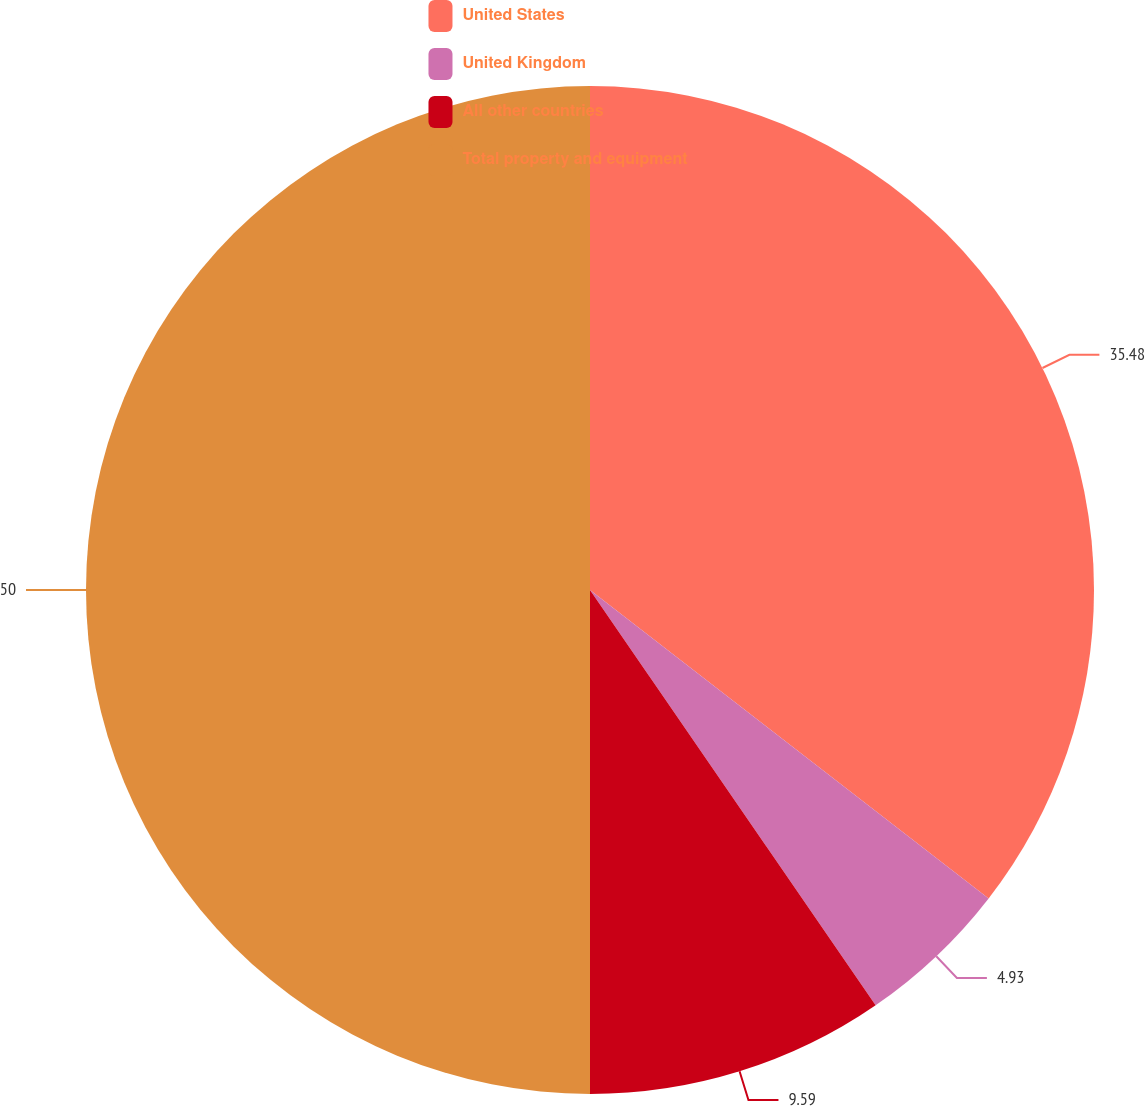Convert chart to OTSL. <chart><loc_0><loc_0><loc_500><loc_500><pie_chart><fcel>United States<fcel>United Kingdom<fcel>All other countries<fcel>Total property and equipment<nl><fcel>35.48%<fcel>4.93%<fcel>9.59%<fcel>50.0%<nl></chart> 